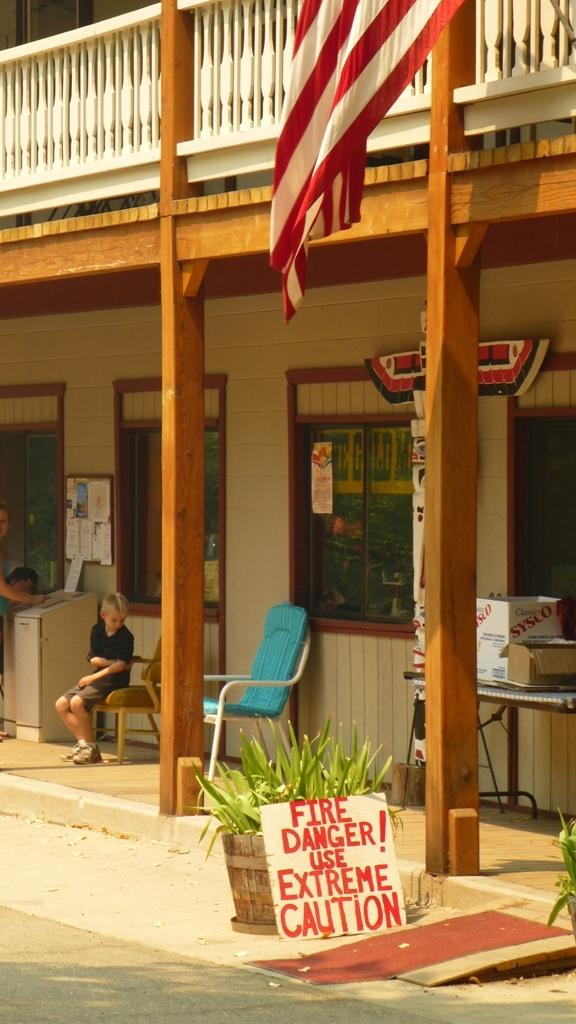How many chairs are visible in the image? There are two chairs in the image. Is anyone sitting on the chairs? Yes, one person is sitting on one of the chairs. What can be seen in the background of the image? There is a building in the image. Are there any plants in the image? Yes, there are potted plants in the image. What else can be seen in the image? There is a board and a flag in the image. Who is the owner of the society depicted in the image? There is no reference to a society or its owner in the image. 